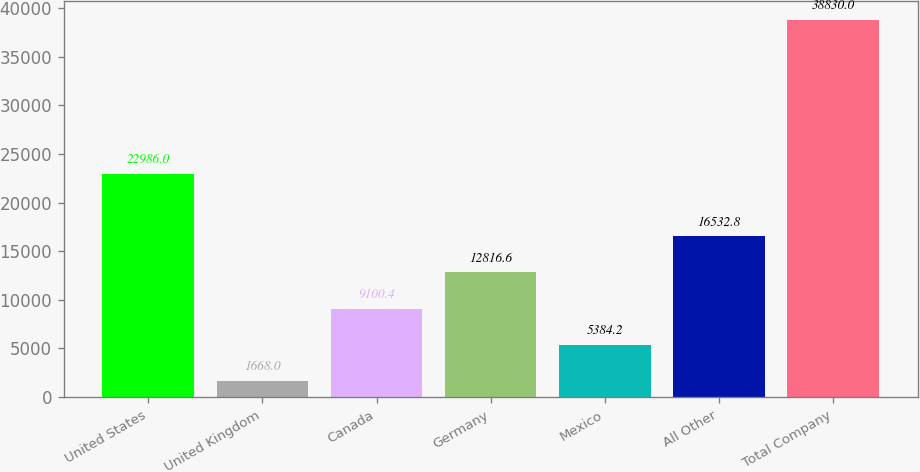Convert chart. <chart><loc_0><loc_0><loc_500><loc_500><bar_chart><fcel>United States<fcel>United Kingdom<fcel>Canada<fcel>Germany<fcel>Mexico<fcel>All Other<fcel>Total Company<nl><fcel>22986<fcel>1668<fcel>9100.4<fcel>12816.6<fcel>5384.2<fcel>16532.8<fcel>38830<nl></chart> 